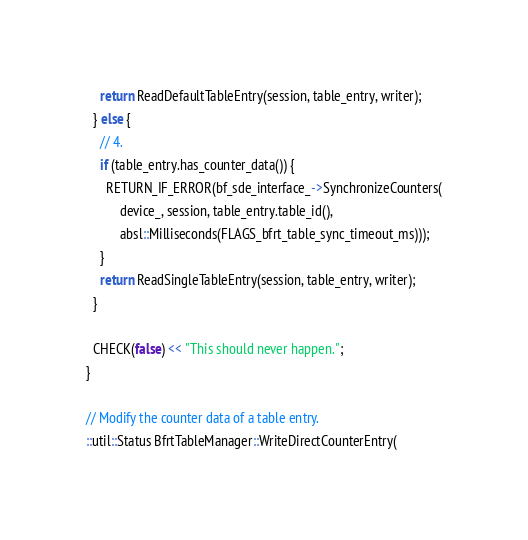<code> <loc_0><loc_0><loc_500><loc_500><_C++_>    return ReadDefaultTableEntry(session, table_entry, writer);
  } else {
    // 4.
    if (table_entry.has_counter_data()) {
      RETURN_IF_ERROR(bf_sde_interface_->SynchronizeCounters(
          device_, session, table_entry.table_id(),
          absl::Milliseconds(FLAGS_bfrt_table_sync_timeout_ms)));
    }
    return ReadSingleTableEntry(session, table_entry, writer);
  }

  CHECK(false) << "This should never happen.";
}

// Modify the counter data of a table entry.
::util::Status BfrtTableManager::WriteDirectCounterEntry(</code> 